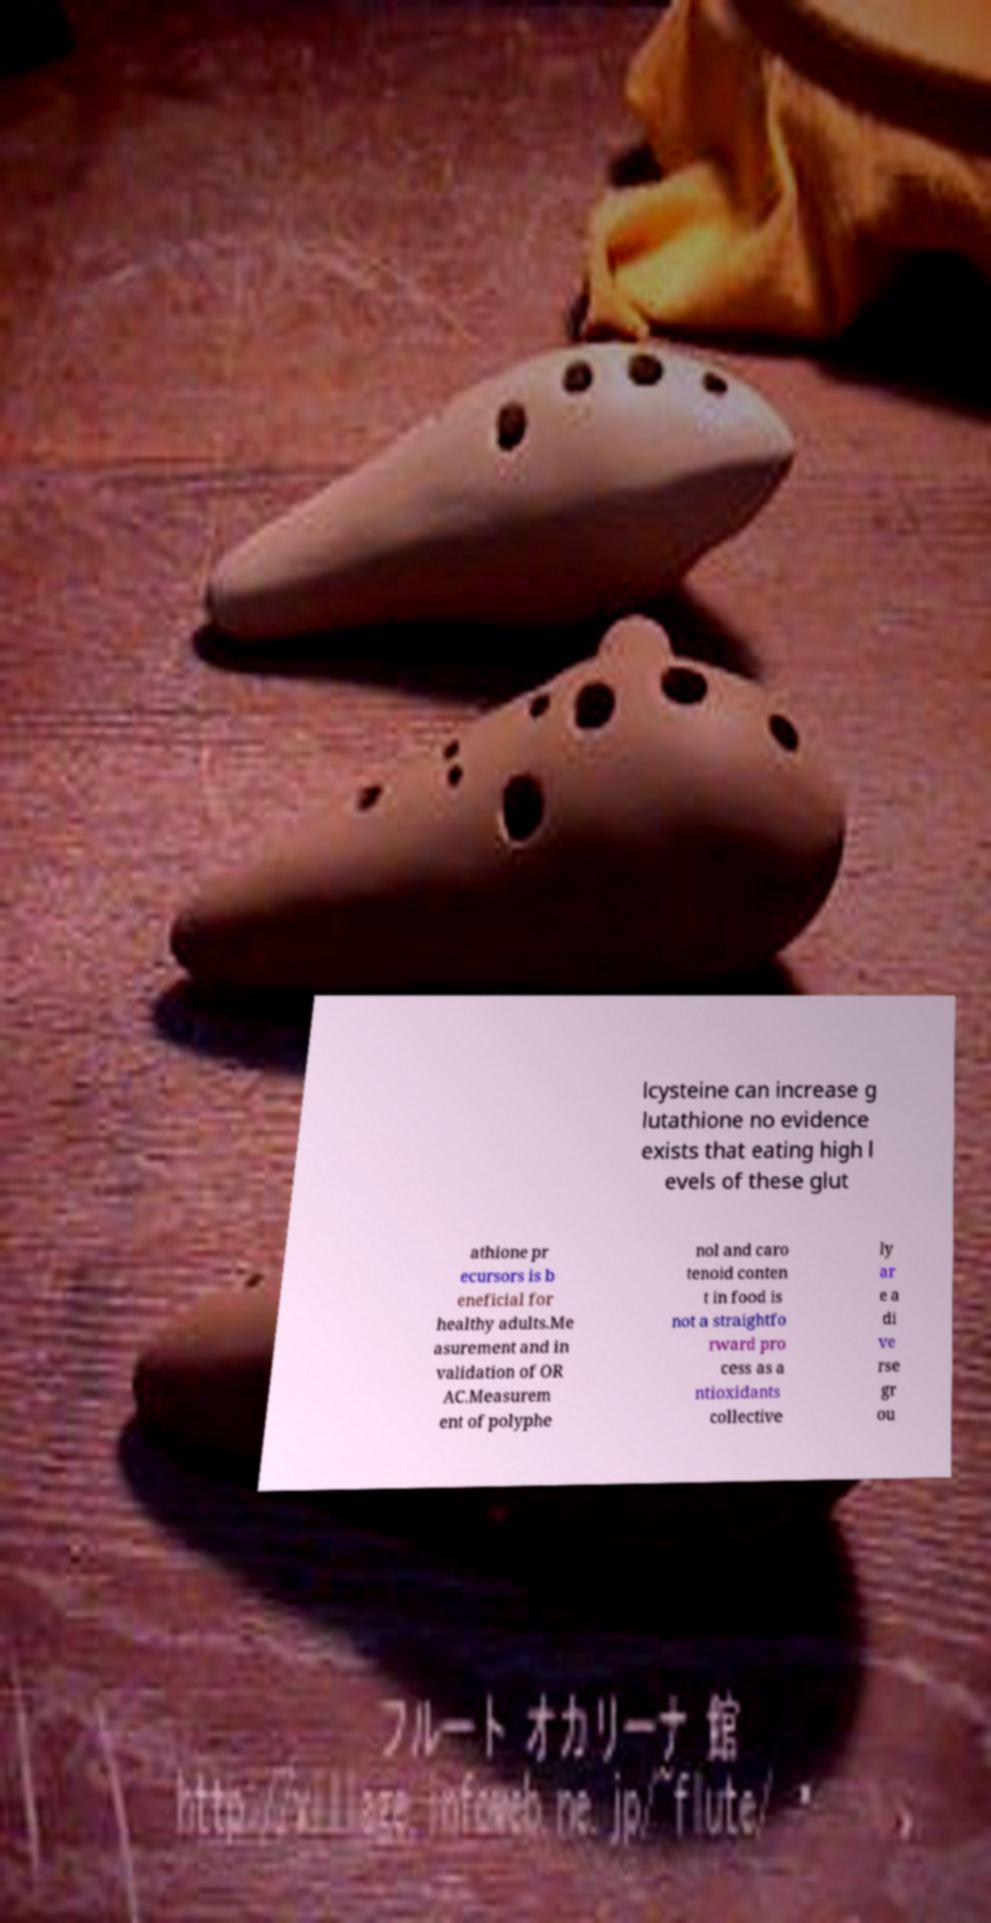Can you read and provide the text displayed in the image?This photo seems to have some interesting text. Can you extract and type it out for me? lcysteine can increase g lutathione no evidence exists that eating high l evels of these glut athione pr ecursors is b eneficial for healthy adults.Me asurement and in validation of OR AC.Measurem ent of polyphe nol and caro tenoid conten t in food is not a straightfo rward pro cess as a ntioxidants collective ly ar e a di ve rse gr ou 